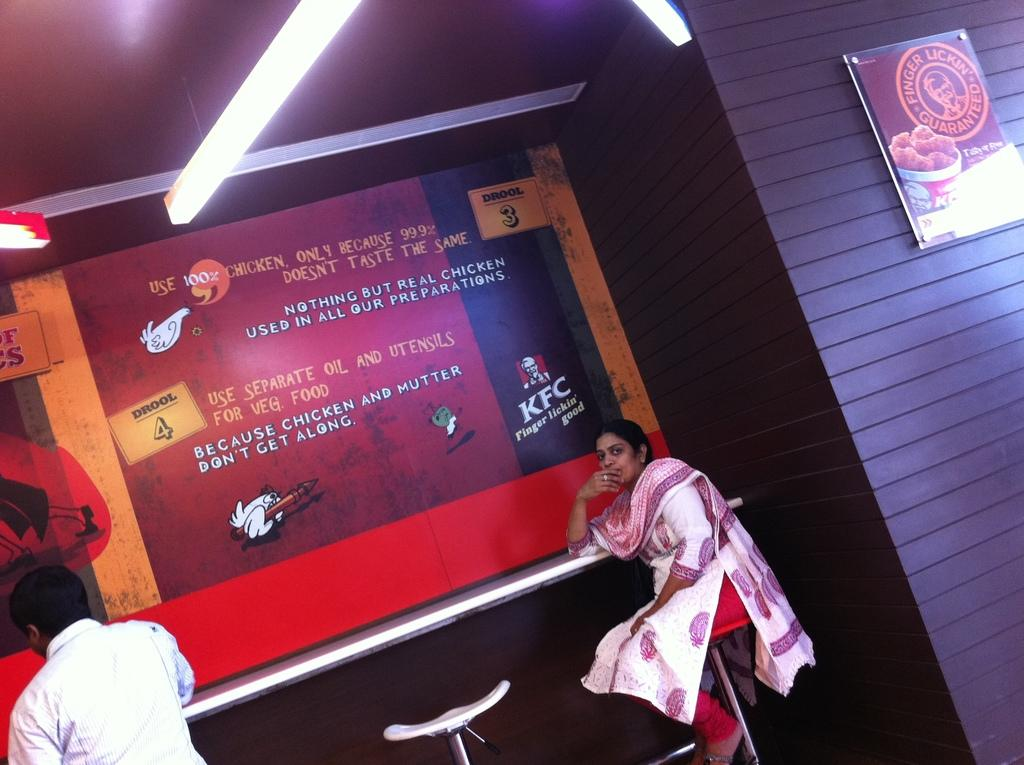<image>
Share a concise interpretation of the image provided. a building with a poster on the wall that says 'because chicken and mutter don't get along' 